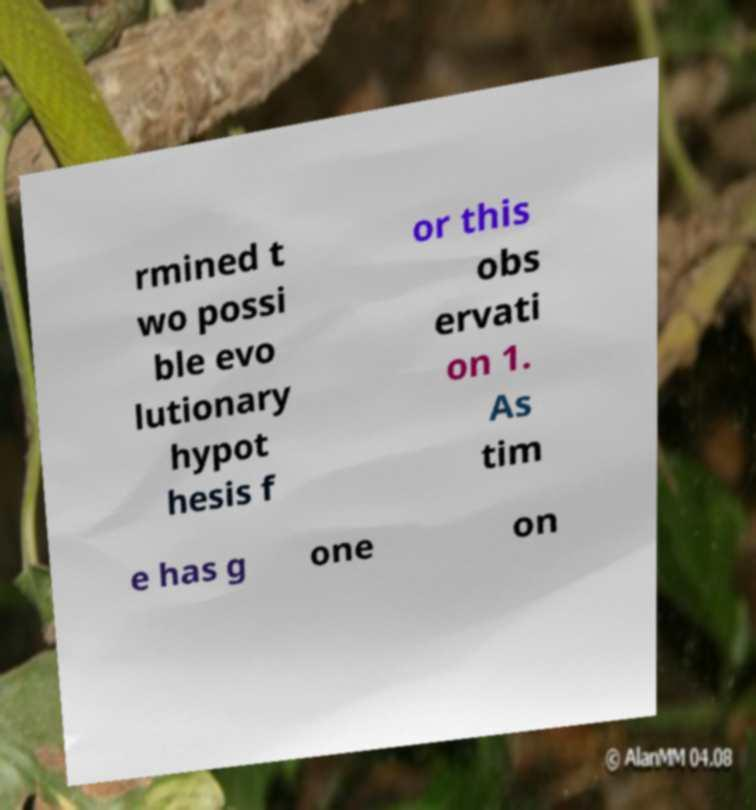There's text embedded in this image that I need extracted. Can you transcribe it verbatim? rmined t wo possi ble evo lutionary hypot hesis f or this obs ervati on 1. As tim e has g one on 